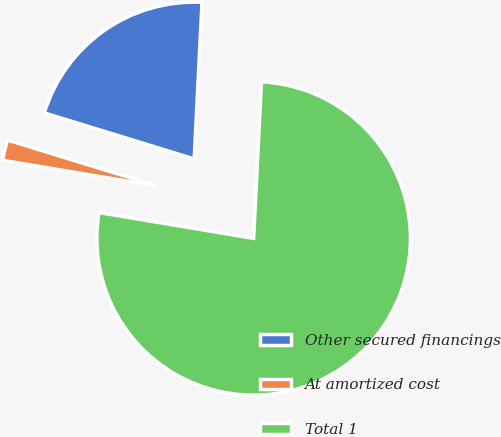Convert chart to OTSL. <chart><loc_0><loc_0><loc_500><loc_500><pie_chart><fcel>Other secured financings<fcel>At amortized cost<fcel>Total 1<nl><fcel>21.05%<fcel>2.11%<fcel>76.84%<nl></chart> 